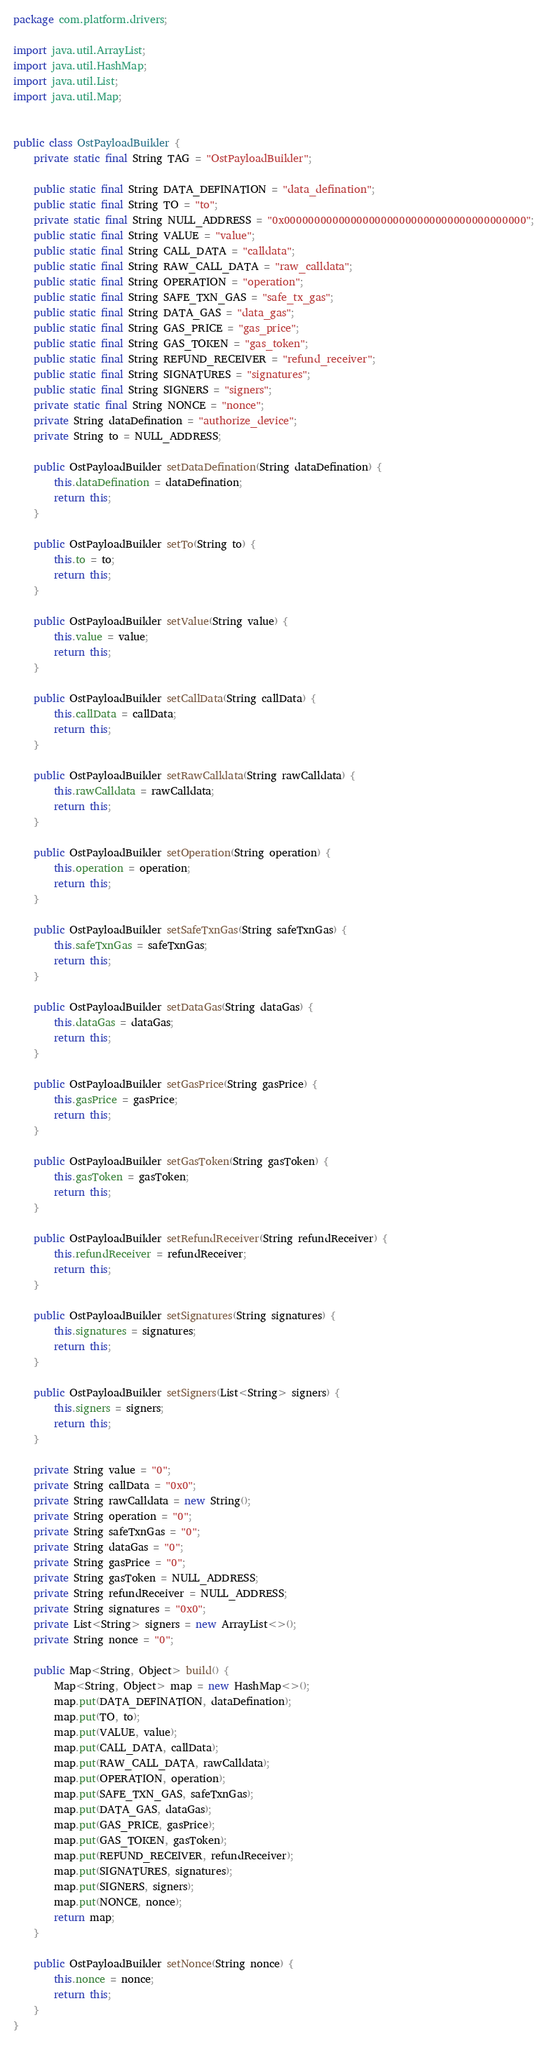<code> <loc_0><loc_0><loc_500><loc_500><_Java_>package com.platform.drivers;

import java.util.ArrayList;
import java.util.HashMap;
import java.util.List;
import java.util.Map;


public class OstPayloadBuilder {
    private static final String TAG = "OstPayloadBuilder";

    public static final String DATA_DEFINATION = "data_defination";
    public static final String TO = "to";
    private static final String NULL_ADDRESS = "0x0000000000000000000000000000000000000000";
    public static final String VALUE = "value";
    public static final String CALL_DATA = "calldata";
    public static final String RAW_CALL_DATA = "raw_calldata";
    public static final String OPERATION = "operation";
    public static final String SAFE_TXN_GAS = "safe_tx_gas";
    public static final String DATA_GAS = "data_gas";
    public static final String GAS_PRICE = "gas_price";
    public static final String GAS_TOKEN = "gas_token";
    public static final String REFUND_RECEIVER = "refund_receiver";
    public static final String SIGNATURES = "signatures";
    public static final String SIGNERS = "signers";
    private static final String NONCE = "nonce";
    private String dataDefination = "authorize_device";
    private String to = NULL_ADDRESS;

    public OstPayloadBuilder setDataDefination(String dataDefination) {
        this.dataDefination = dataDefination;
        return this;
    }

    public OstPayloadBuilder setTo(String to) {
        this.to = to;
        return this;
    }

    public OstPayloadBuilder setValue(String value) {
        this.value = value;
        return this;
    }

    public OstPayloadBuilder setCallData(String callData) {
        this.callData = callData;
        return this;
    }

    public OstPayloadBuilder setRawCalldata(String rawCalldata) {
        this.rawCalldata = rawCalldata;
        return this;
    }

    public OstPayloadBuilder setOperation(String operation) {
        this.operation = operation;
        return this;
    }

    public OstPayloadBuilder setSafeTxnGas(String safeTxnGas) {
        this.safeTxnGas = safeTxnGas;
        return this;
    }

    public OstPayloadBuilder setDataGas(String dataGas) {
        this.dataGas = dataGas;
        return this;
    }

    public OstPayloadBuilder setGasPrice(String gasPrice) {
        this.gasPrice = gasPrice;
        return this;
    }

    public OstPayloadBuilder setGasToken(String gasToken) {
        this.gasToken = gasToken;
        return this;
    }

    public OstPayloadBuilder setRefundReceiver(String refundReceiver) {
        this.refundReceiver = refundReceiver;
        return this;
    }

    public OstPayloadBuilder setSignatures(String signatures) {
        this.signatures = signatures;
        return this;
    }

    public OstPayloadBuilder setSigners(List<String> signers) {
        this.signers = signers;
        return this;
    }

    private String value = "0";
    private String callData = "0x0";
    private String rawCalldata = new String();
    private String operation = "0";
    private String safeTxnGas = "0";
    private String dataGas = "0";
    private String gasPrice = "0";
    private String gasToken = NULL_ADDRESS;
    private String refundReceiver = NULL_ADDRESS;
    private String signatures = "0x0";
    private List<String> signers = new ArrayList<>();
    private String nonce = "0";

    public Map<String, Object> build() {
        Map<String, Object> map = new HashMap<>();
        map.put(DATA_DEFINATION, dataDefination);
        map.put(TO, to);
        map.put(VALUE, value);
        map.put(CALL_DATA, callData);
        map.put(RAW_CALL_DATA, rawCalldata);
        map.put(OPERATION, operation);
        map.put(SAFE_TXN_GAS, safeTxnGas);
        map.put(DATA_GAS, dataGas);
        map.put(GAS_PRICE, gasPrice);
        map.put(GAS_TOKEN, gasToken);
        map.put(REFUND_RECEIVER, refundReceiver);
        map.put(SIGNATURES, signatures);
        map.put(SIGNERS, signers);
        map.put(NONCE, nonce);
        return map;
    }

    public OstPayloadBuilder setNonce(String nonce) {
        this.nonce = nonce;
        return this;
    }
}</code> 